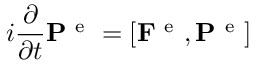<formula> <loc_0><loc_0><loc_500><loc_500>i \frac { \partial } { \partial t } P ^ { e } = \left [ F ^ { e } , P ^ { e } \right ]</formula> 